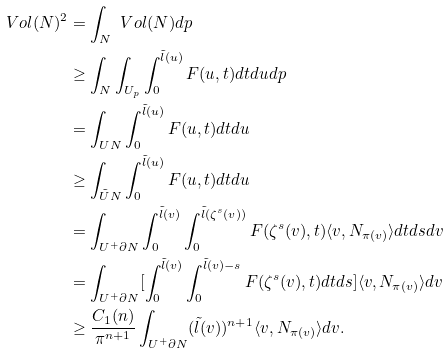Convert formula to latex. <formula><loc_0><loc_0><loc_500><loc_500>\ V o l ( N ) ^ { 2 } & = \int _ { N } \ V o l ( N ) d p \\ & \geq \int _ { N } \int _ { U _ { p } } \int _ { 0 } ^ { \tilde { l } ( u ) } F ( u , t ) d t d u d p \\ & = \int _ { U N } \int _ { 0 } ^ { \tilde { l } ( u ) } F ( u , t ) d t d u \\ & \geq \int _ { \tilde { U } N } \int _ { 0 } ^ { \tilde { l } ( u ) } F ( u , t ) d t d u \\ & = \int _ { U ^ { + } \partial N } \int _ { 0 } ^ { \tilde { l } ( v ) } \int _ { 0 } ^ { \tilde { l } ( \zeta ^ { s } ( v ) ) } F ( \zeta ^ { s } ( v ) , t ) \langle v , N _ { \pi ( v ) } \rangle d t d s d v \\ & = \int _ { U ^ { + } \partial N } [ \int _ { 0 } ^ { \tilde { l } ( v ) } \int _ { 0 } ^ { \tilde { l } ( v ) - s } F ( \zeta ^ { s } ( v ) , t ) d t d s ] \langle v , N _ { \pi ( v ) } \rangle d v \\ & \geq \frac { C _ { 1 } ( n ) } { \pi ^ { n + 1 } } \int _ { U ^ { + } \partial N } ( \tilde { l } ( v ) ) ^ { n + 1 } \langle v , N _ { \pi ( v ) } \rangle d v .</formula> 